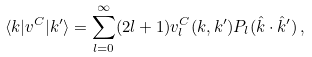Convert formula to latex. <formula><loc_0><loc_0><loc_500><loc_500>\langle { k } | v ^ { C } | { k } ^ { \prime } \rangle = \sum _ { l = 0 } ^ { \infty } ( 2 l + 1 ) v _ { l } ^ { C } ( k , k ^ { \prime } ) P _ { l } ( \hat { k } \cdot \hat { k } ^ { \prime } ) \, ,</formula> 